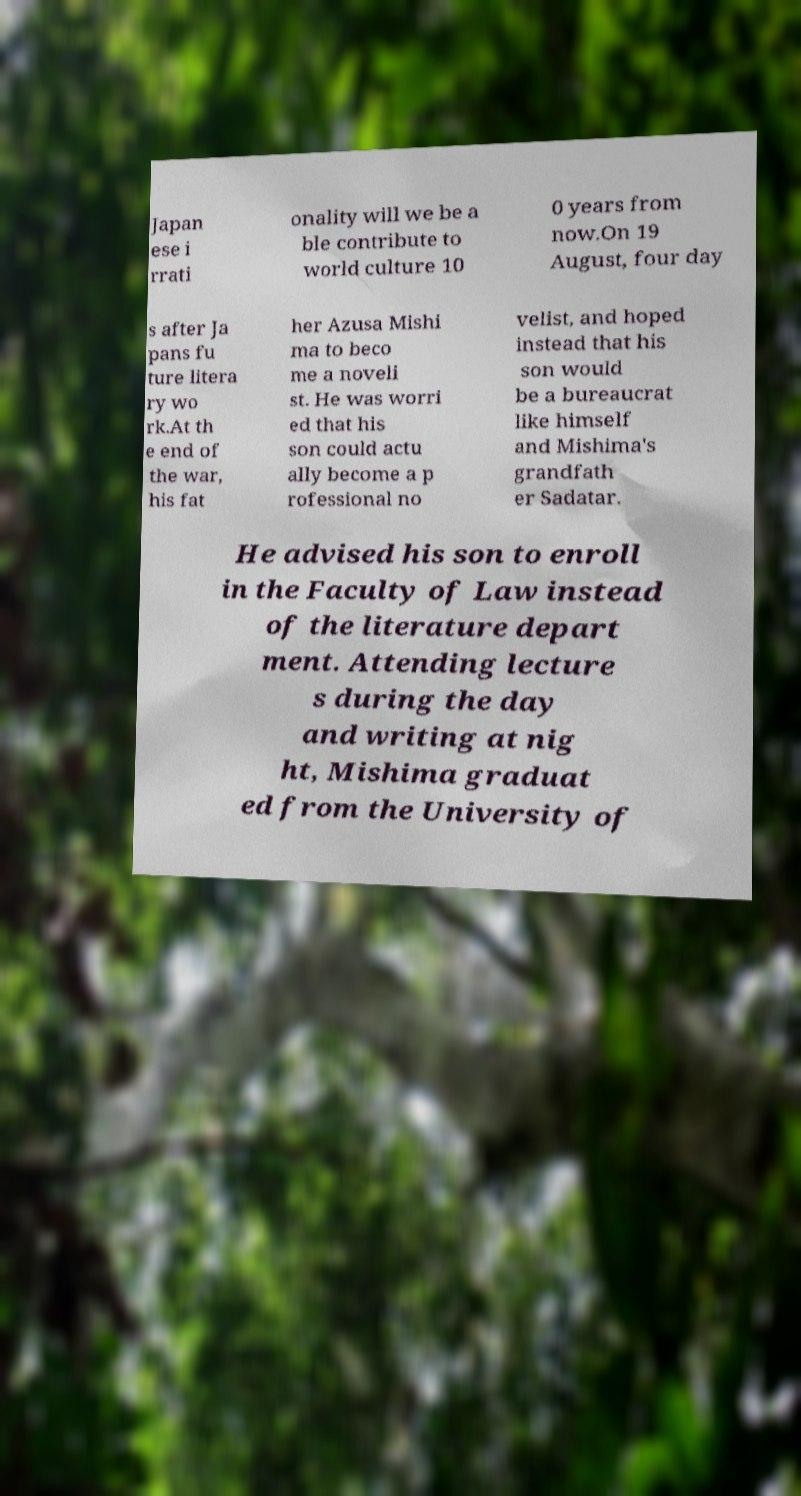Please read and relay the text visible in this image. What does it say? Japan ese i rrati onality will we be a ble contribute to world culture 10 0 years from now.On 19 August, four day s after Ja pans fu ture litera ry wo rk.At th e end of the war, his fat her Azusa Mishi ma to beco me a noveli st. He was worri ed that his son could actu ally become a p rofessional no velist, and hoped instead that his son would be a bureaucrat like himself and Mishima's grandfath er Sadatar. He advised his son to enroll in the Faculty of Law instead of the literature depart ment. Attending lecture s during the day and writing at nig ht, Mishima graduat ed from the University of 